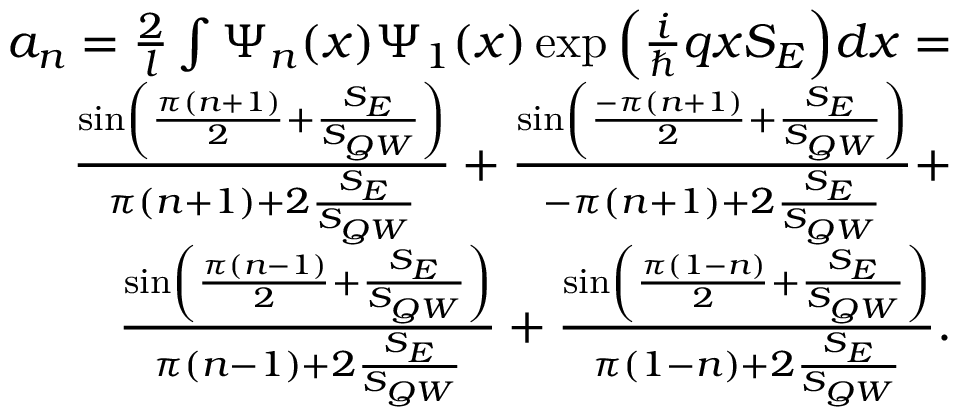Convert formula to latex. <formula><loc_0><loc_0><loc_500><loc_500>\begin{array} { r } { a _ { n } = \frac { 2 } { l } \int \Psi _ { n } ( x ) \Psi _ { 1 } ( x ) \exp { \left ( \frac { i } { } q x S _ { E } \right ) } d x = } \\ { \frac { \sin \left ( \frac { \pi ( n + 1 ) } { 2 } + \frac { S _ { E } } { S _ { Q W } } \right ) } { \pi ( n + 1 ) + 2 \frac { S _ { E } } { S _ { Q W } } } + \frac { \sin \left ( \frac { - \pi ( n + 1 ) } { 2 } + \frac { S _ { E } } { S _ { Q W } } \right ) } { - \pi ( n + 1 ) + 2 \frac { S _ { E } } { S _ { Q W } } } + } \\ { \frac { \sin \left ( \frac { \pi ( n - 1 ) } { 2 } + \frac { S _ { E } } { S _ { Q W } } \right ) } { \pi ( n - 1 ) + 2 \frac { S _ { E } } { S _ { Q W } } } + \frac { \sin \left ( \frac { \pi ( 1 - n ) } { 2 } + \frac { S _ { E } } { S _ { Q W } } \right ) } { \pi ( 1 - n ) + 2 \frac { S _ { E } } { S _ { Q W } } } . } \end{array}</formula> 